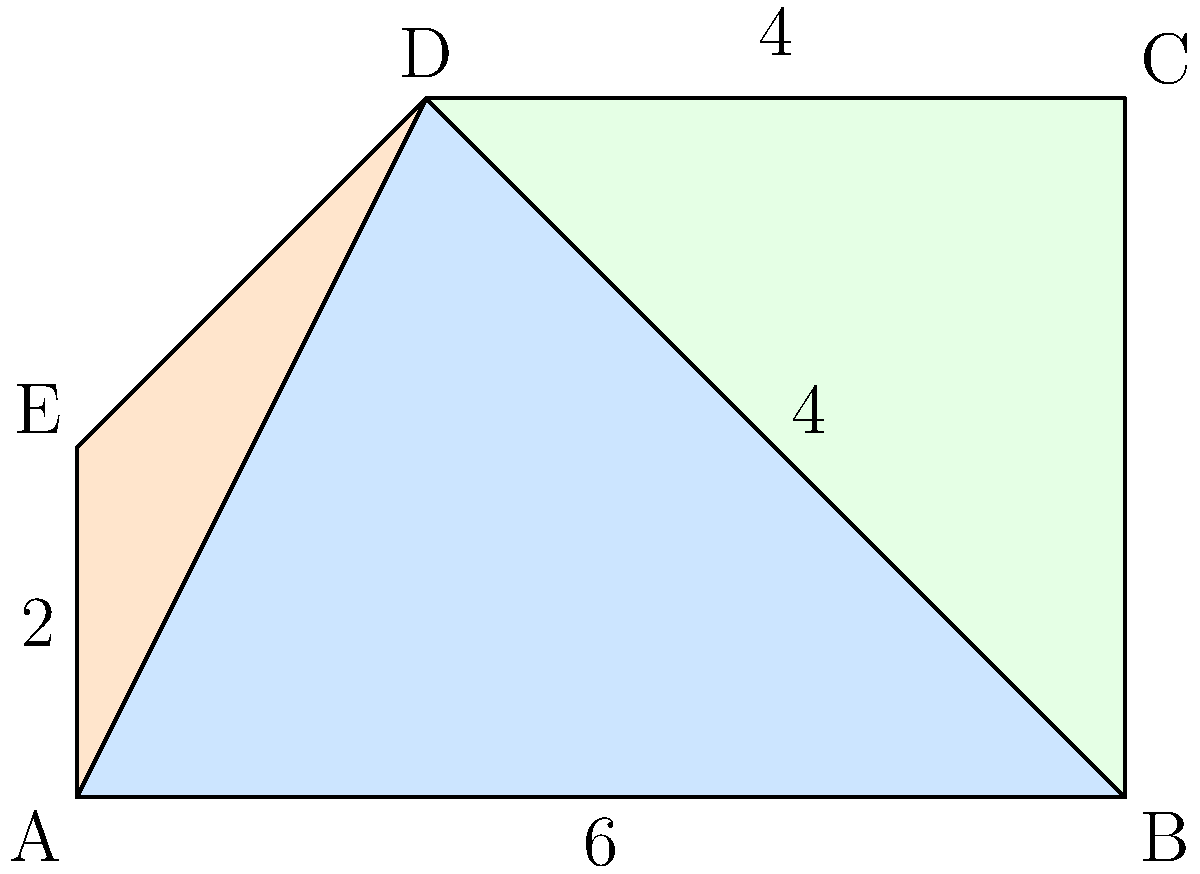In Wallingford, Connecticut, a new voting district map has been proposed. The map forms a polygon ABCDE, as shown above. If the scale of the map is 1 unit = 1 mile, what is the total area of the proposed voting district in square miles? To find the area of the polygon ABCDE, we can divide it into three triangles: ABD, BCD, and ADE. Then we can calculate the area of each triangle and sum them up.

1. Area of triangle ABD:
   Base = 6 miles, Height = 4 miles
   Area_ABD = $\frac{1}{2} \times 6 \times 4 = 12$ square miles

2. Area of triangle BCD:
   Base = 4 miles, Height = 4 miles
   Area_BCD = $\frac{1}{2} \times 4 \times 4 = 8$ square miles

3. Area of triangle ADE:
   Base = 2 miles, Height = 2 miles
   Area_ADE = $\frac{1}{2} \times 2 \times 2 = 2$ square miles

4. Total area of polygon ABCDE:
   Total Area = Area_ABD + Area_BCD + Area_ADE
   Total Area = $12 + 8 + 2 = 22$ square miles

Therefore, the total area of the proposed voting district is 22 square miles.
Answer: 22 square miles 